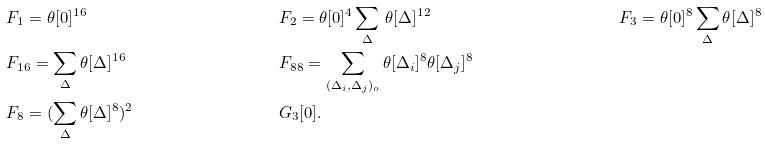<formula> <loc_0><loc_0><loc_500><loc_500>& F _ { 1 } = \theta [ 0 ] ^ { 1 6 } & & F _ { 2 } = \theta [ 0 ] ^ { 4 } \sum _ { \Delta } \, \theta [ \Delta ] ^ { 1 2 } & & F _ { 3 } = \theta [ 0 ] ^ { 8 } \sum _ { \Delta } \theta [ \Delta ] ^ { 8 } \\ & F _ { 1 6 } = \sum _ { \Delta } \theta [ \Delta ] ^ { 1 6 } & & F _ { 8 8 } = \sum _ { ( \Delta _ { i } , \Delta _ { j } ) _ { o } } \theta [ \Delta _ { i } ] ^ { 8 } \theta [ \Delta _ { j } ] ^ { 8 } \\ & F _ { 8 } = ( \sum _ { \Delta } \theta [ \Delta ] ^ { 8 } ) ^ { 2 } & & G _ { 3 } [ 0 ] .</formula> 